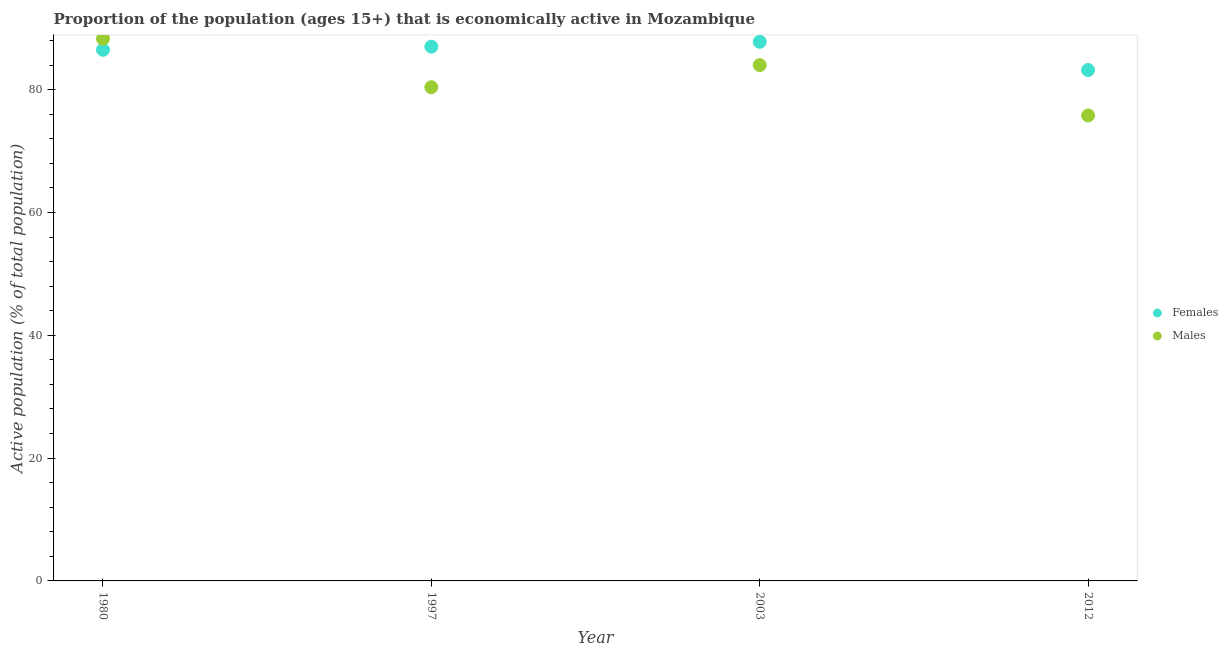How many different coloured dotlines are there?
Your answer should be very brief. 2. What is the percentage of economically active male population in 2003?
Keep it short and to the point. 84. Across all years, what is the maximum percentage of economically active female population?
Provide a succinct answer. 87.8. Across all years, what is the minimum percentage of economically active female population?
Your answer should be compact. 83.2. In which year was the percentage of economically active female population minimum?
Your response must be concise. 2012. What is the total percentage of economically active male population in the graph?
Your answer should be very brief. 328.5. What is the difference between the percentage of economically active female population in 1997 and that in 2003?
Your answer should be compact. -0.8. What is the average percentage of economically active male population per year?
Provide a short and direct response. 82.13. In the year 2012, what is the difference between the percentage of economically active female population and percentage of economically active male population?
Your response must be concise. 7.4. What is the ratio of the percentage of economically active female population in 1980 to that in 1997?
Provide a short and direct response. 0.99. Is the percentage of economically active male population in 1980 less than that in 1997?
Your answer should be very brief. No. Is the difference between the percentage of economically active male population in 1980 and 2003 greater than the difference between the percentage of economically active female population in 1980 and 2003?
Make the answer very short. Yes. What is the difference between the highest and the second highest percentage of economically active male population?
Offer a terse response. 4.3. What is the difference between the highest and the lowest percentage of economically active female population?
Offer a very short reply. 4.6. In how many years, is the percentage of economically active female population greater than the average percentage of economically active female population taken over all years?
Provide a succinct answer. 3. Is the sum of the percentage of economically active male population in 1997 and 2003 greater than the maximum percentage of economically active female population across all years?
Provide a succinct answer. Yes. Does the percentage of economically active male population monotonically increase over the years?
Your answer should be compact. No. What is the difference between two consecutive major ticks on the Y-axis?
Provide a succinct answer. 20. Are the values on the major ticks of Y-axis written in scientific E-notation?
Give a very brief answer. No. Does the graph contain any zero values?
Your answer should be very brief. No. Where does the legend appear in the graph?
Make the answer very short. Center right. How many legend labels are there?
Your answer should be compact. 2. What is the title of the graph?
Your answer should be very brief. Proportion of the population (ages 15+) that is economically active in Mozambique. Does "Age 65(male)" appear as one of the legend labels in the graph?
Ensure brevity in your answer.  No. What is the label or title of the Y-axis?
Offer a terse response. Active population (% of total population). What is the Active population (% of total population) of Females in 1980?
Provide a succinct answer. 86.5. What is the Active population (% of total population) of Males in 1980?
Make the answer very short. 88.3. What is the Active population (% of total population) of Females in 1997?
Give a very brief answer. 87. What is the Active population (% of total population) of Males in 1997?
Provide a short and direct response. 80.4. What is the Active population (% of total population) of Females in 2003?
Your response must be concise. 87.8. What is the Active population (% of total population) of Females in 2012?
Provide a short and direct response. 83.2. What is the Active population (% of total population) of Males in 2012?
Provide a succinct answer. 75.8. Across all years, what is the maximum Active population (% of total population) of Females?
Ensure brevity in your answer.  87.8. Across all years, what is the maximum Active population (% of total population) in Males?
Offer a very short reply. 88.3. Across all years, what is the minimum Active population (% of total population) of Females?
Make the answer very short. 83.2. Across all years, what is the minimum Active population (% of total population) in Males?
Keep it short and to the point. 75.8. What is the total Active population (% of total population) in Females in the graph?
Give a very brief answer. 344.5. What is the total Active population (% of total population) of Males in the graph?
Your response must be concise. 328.5. What is the difference between the Active population (% of total population) in Males in 1980 and that in 2003?
Your answer should be very brief. 4.3. What is the difference between the Active population (% of total population) in Males in 1980 and that in 2012?
Offer a very short reply. 12.5. What is the difference between the Active population (% of total population) in Females in 1997 and that in 2003?
Your response must be concise. -0.8. What is the difference between the Active population (% of total population) of Females in 1997 and that in 2012?
Provide a succinct answer. 3.8. What is the difference between the Active population (% of total population) of Males in 1997 and that in 2012?
Keep it short and to the point. 4.6. What is the difference between the Active population (% of total population) of Females in 2003 and that in 2012?
Make the answer very short. 4.6. What is the difference between the Active population (% of total population) of Females in 1980 and the Active population (% of total population) of Males in 1997?
Give a very brief answer. 6.1. What is the difference between the Active population (% of total population) of Females in 1980 and the Active population (% of total population) of Males in 2003?
Make the answer very short. 2.5. What is the difference between the Active population (% of total population) of Females in 1997 and the Active population (% of total population) of Males in 2003?
Make the answer very short. 3. What is the difference between the Active population (% of total population) in Females in 1997 and the Active population (% of total population) in Males in 2012?
Give a very brief answer. 11.2. What is the average Active population (% of total population) of Females per year?
Your answer should be compact. 86.12. What is the average Active population (% of total population) in Males per year?
Give a very brief answer. 82.12. What is the ratio of the Active population (% of total population) in Females in 1980 to that in 1997?
Keep it short and to the point. 0.99. What is the ratio of the Active population (% of total population) of Males in 1980 to that in 1997?
Offer a terse response. 1.1. What is the ratio of the Active population (% of total population) in Females in 1980 to that in 2003?
Provide a short and direct response. 0.99. What is the ratio of the Active population (% of total population) of Males in 1980 to that in 2003?
Give a very brief answer. 1.05. What is the ratio of the Active population (% of total population) of Females in 1980 to that in 2012?
Your answer should be compact. 1.04. What is the ratio of the Active population (% of total population) of Males in 1980 to that in 2012?
Offer a very short reply. 1.16. What is the ratio of the Active population (% of total population) in Females in 1997 to that in 2003?
Offer a terse response. 0.99. What is the ratio of the Active population (% of total population) of Males in 1997 to that in 2003?
Provide a short and direct response. 0.96. What is the ratio of the Active population (% of total population) in Females in 1997 to that in 2012?
Ensure brevity in your answer.  1.05. What is the ratio of the Active population (% of total population) of Males in 1997 to that in 2012?
Your response must be concise. 1.06. What is the ratio of the Active population (% of total population) in Females in 2003 to that in 2012?
Your response must be concise. 1.06. What is the ratio of the Active population (% of total population) in Males in 2003 to that in 2012?
Provide a succinct answer. 1.11. What is the difference between the highest and the second highest Active population (% of total population) of Females?
Keep it short and to the point. 0.8. What is the difference between the highest and the second highest Active population (% of total population) of Males?
Provide a short and direct response. 4.3. What is the difference between the highest and the lowest Active population (% of total population) of Males?
Provide a succinct answer. 12.5. 